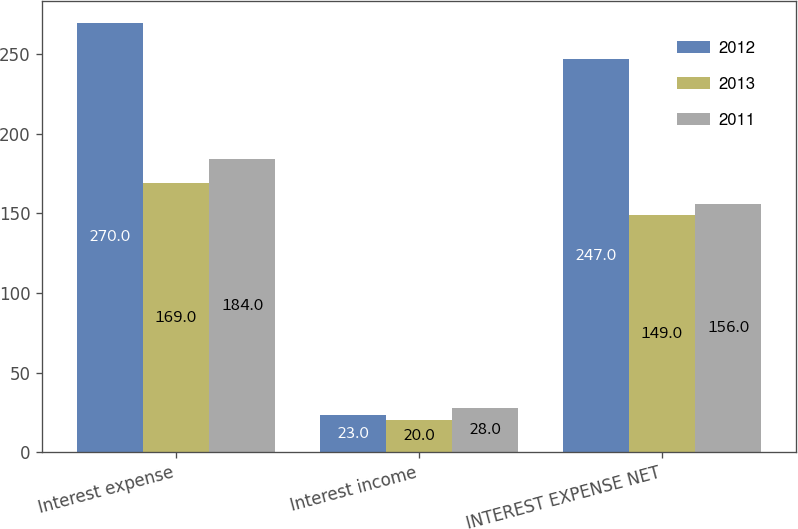Convert chart to OTSL. <chart><loc_0><loc_0><loc_500><loc_500><stacked_bar_chart><ecel><fcel>Interest expense<fcel>Interest income<fcel>INTEREST EXPENSE NET<nl><fcel>2012<fcel>270<fcel>23<fcel>247<nl><fcel>2013<fcel>169<fcel>20<fcel>149<nl><fcel>2011<fcel>184<fcel>28<fcel>156<nl></chart> 